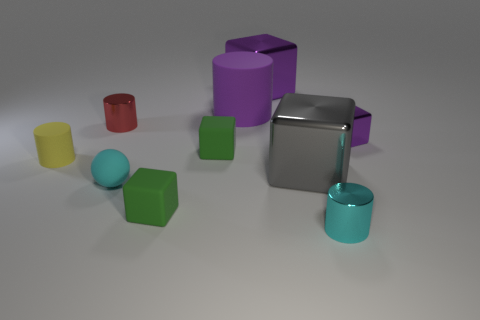Is there anything else that has the same shape as the tiny cyan matte thing?
Give a very brief answer. No. There is a purple thing that is in front of the red cylinder behind the tiny shiny cube; what is its shape?
Ensure brevity in your answer.  Cube. Is the number of yellow rubber cylinders behind the red metallic cylinder less than the number of purple cubes that are behind the big cylinder?
Keep it short and to the point. Yes. The purple rubber thing that is the same shape as the small red object is what size?
Keep it short and to the point. Large. What number of things are either tiny cubes to the left of the big cylinder or matte objects that are in front of the matte ball?
Provide a short and direct response. 2. Is the gray thing the same size as the purple cylinder?
Provide a succinct answer. Yes. Is the number of small purple metallic cylinders greater than the number of big metal things?
Offer a very short reply. No. How many other objects are the same color as the large cylinder?
Ensure brevity in your answer.  2. What number of objects are tiny red spheres or small red cylinders?
Your response must be concise. 1. There is a tiny thing behind the small purple cube; is its shape the same as the small yellow object?
Your answer should be very brief. Yes. 